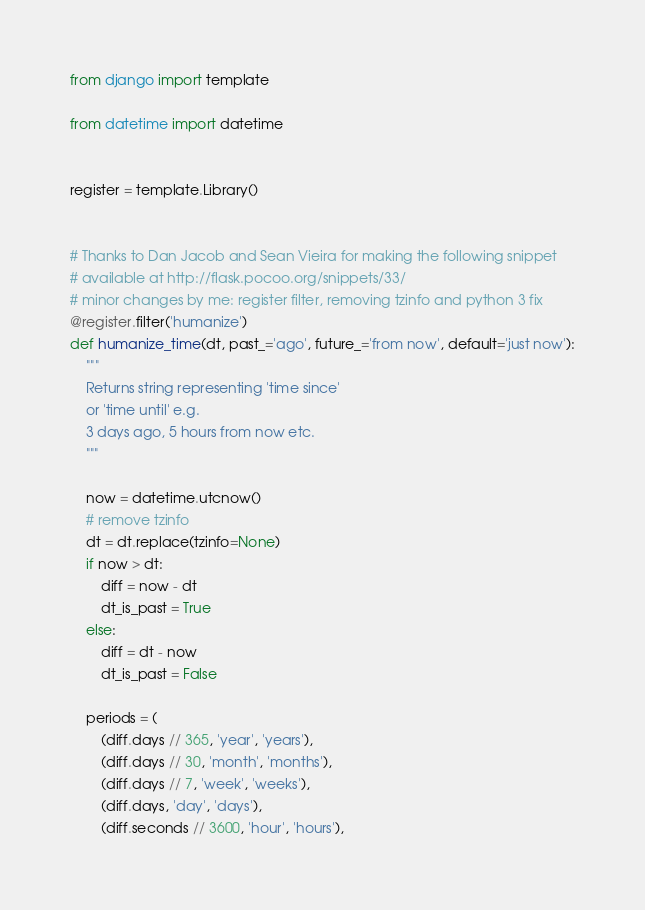<code> <loc_0><loc_0><loc_500><loc_500><_Python_>from django import template

from datetime import datetime


register = template.Library()


# Thanks to Dan Jacob and Sean Vieira for making the following snippet
# available at http://flask.pocoo.org/snippets/33/
# minor changes by me: register filter, removing tzinfo and python 3 fix
@register.filter('humanize')
def humanize_time(dt, past_='ago', future_='from now', default='just now'):
    """
    Returns string representing 'time since'
    or 'time until' e.g.
    3 days ago, 5 hours from now etc.
    """

    now = datetime.utcnow()
    # remove tzinfo
    dt = dt.replace(tzinfo=None)
    if now > dt:
        diff = now - dt
        dt_is_past = True
    else:
        diff = dt - now
        dt_is_past = False

    periods = (
        (diff.days // 365, 'year', 'years'),
        (diff.days // 30, 'month', 'months'),
        (diff.days // 7, 'week', 'weeks'),
        (diff.days, 'day', 'days'),
        (diff.seconds // 3600, 'hour', 'hours'),</code> 